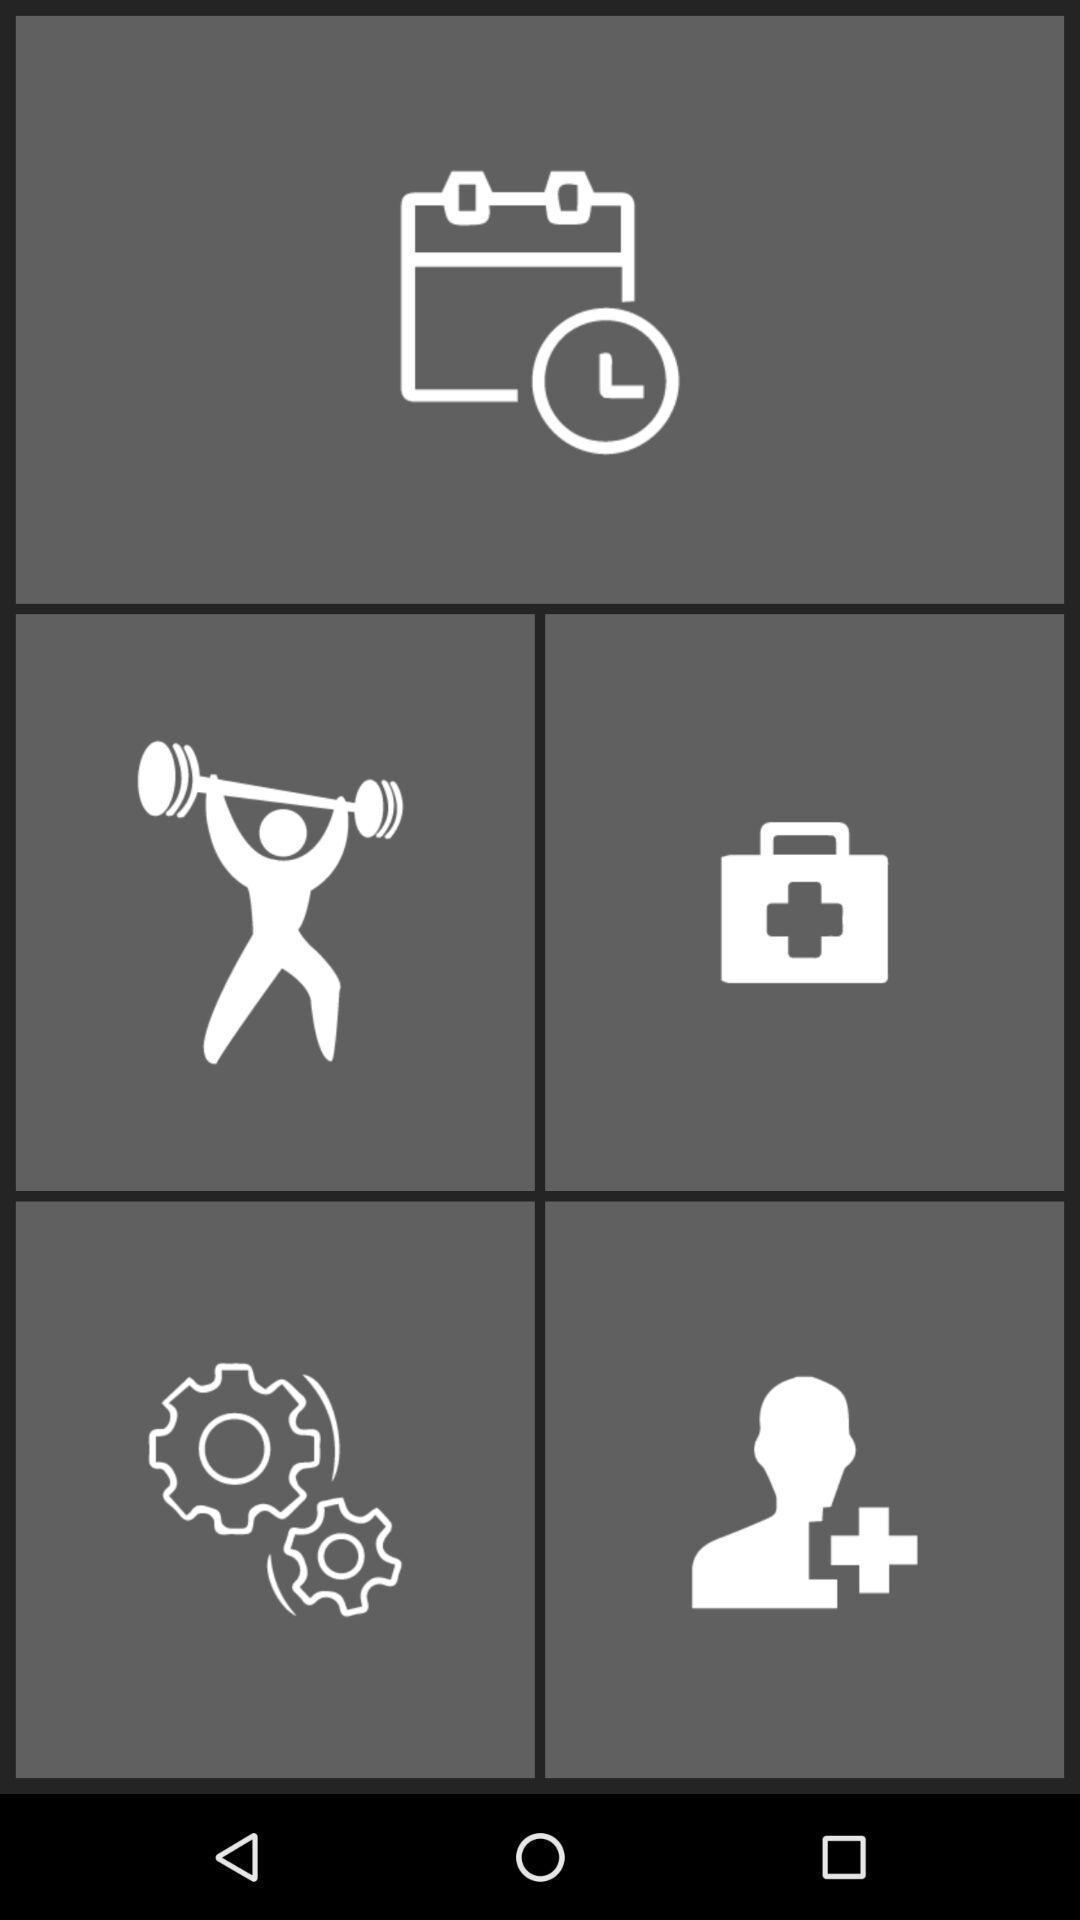Provide a textual representation of this image. Screen page displaying various icons. 